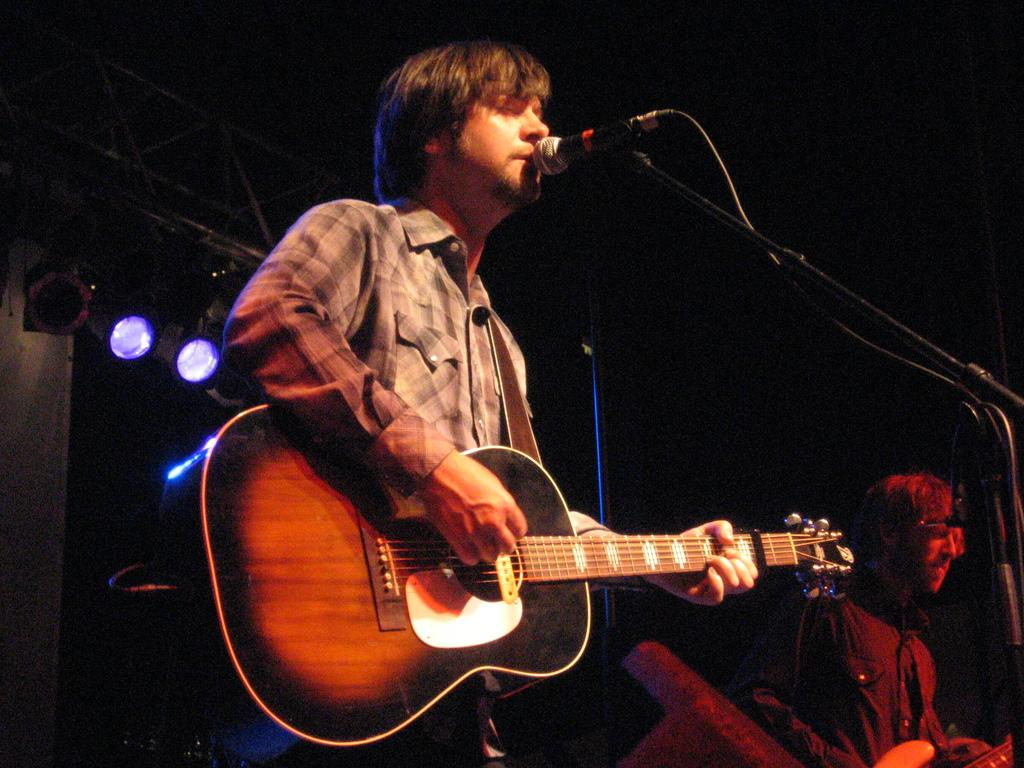What is the man in the image doing? The man is singing on a microphone and playing a guitar. What can be seen in the background of the image? There are lights visible in the background of the image. What type of wire is the tiger holding in the image? There is no tiger or wire present in the image. How many balloons are tied to the microphone in the image? There are no balloons visible in the image. 